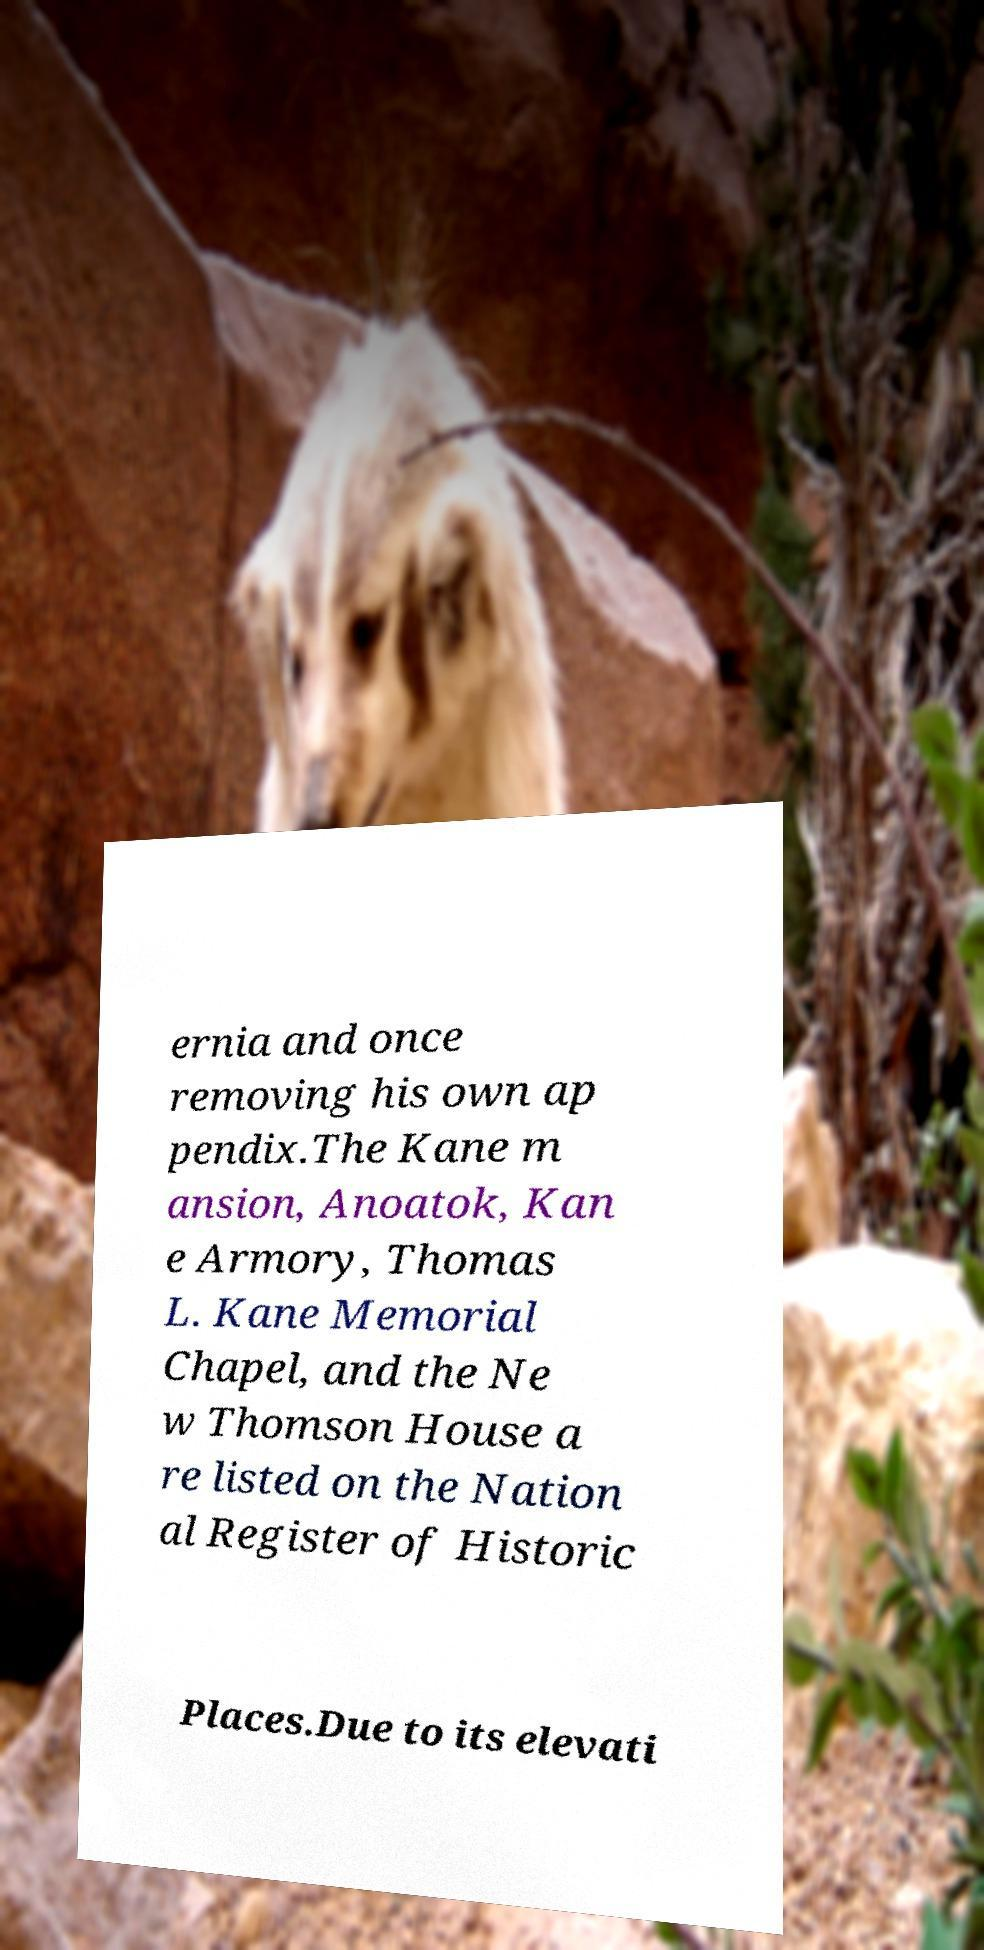Please read and relay the text visible in this image. What does it say? ernia and once removing his own ap pendix.The Kane m ansion, Anoatok, Kan e Armory, Thomas L. Kane Memorial Chapel, and the Ne w Thomson House a re listed on the Nation al Register of Historic Places.Due to its elevati 